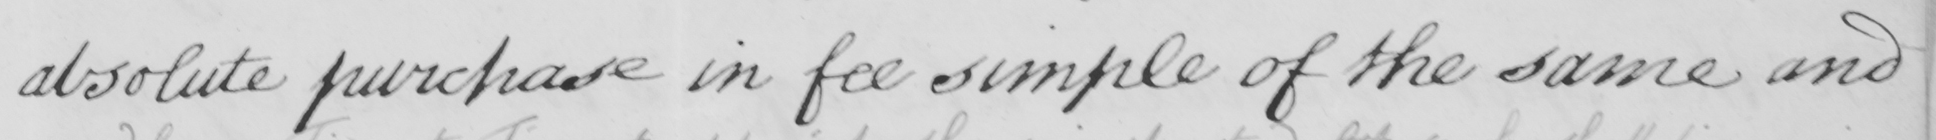What does this handwritten line say? absolute purchase in fee simple of the same and 